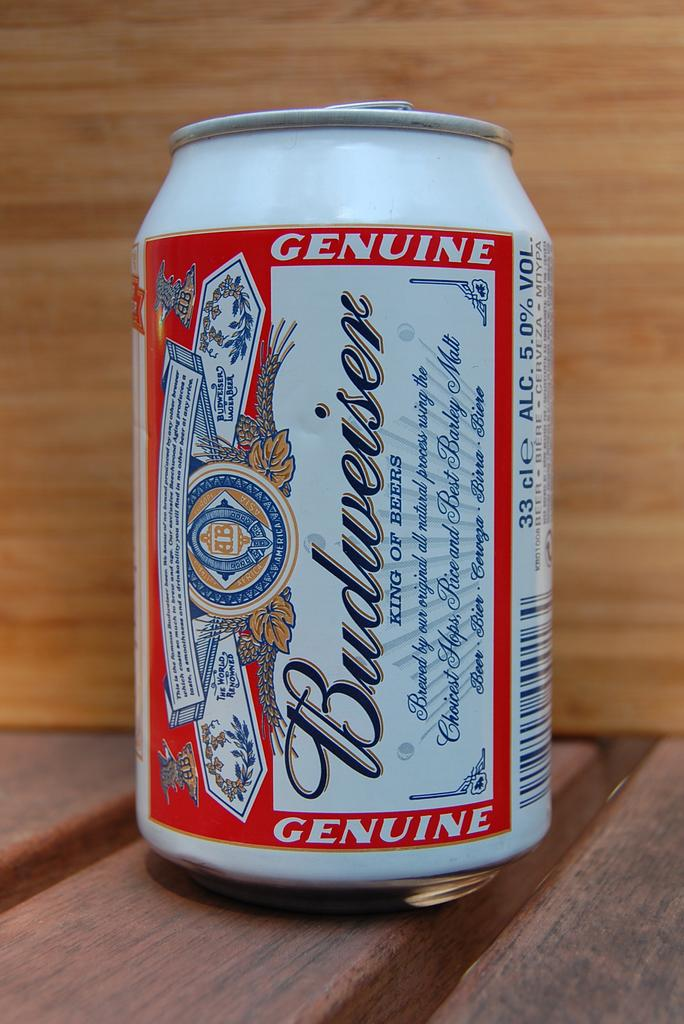<image>
Relay a brief, clear account of the picture shown. A 12 Ounce can of budweiser beer on wood 